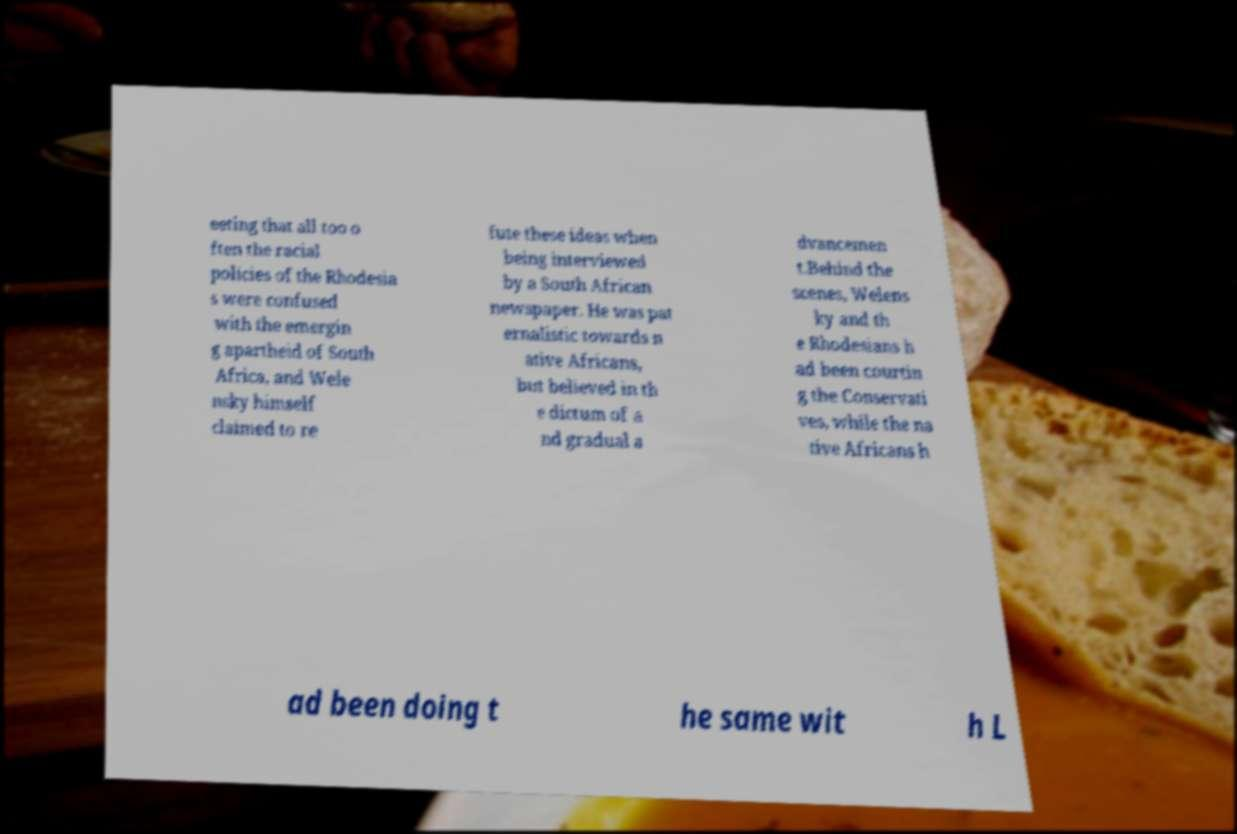Could you assist in decoding the text presented in this image and type it out clearly? eeting that all too o ften the racial policies of the Rhodesia s were confused with the emergin g apartheid of South Africa, and Wele nsky himself claimed to re fute these ideas when being interviewed by a South African newspaper. He was pat ernalistic towards n ative Africans, but believed in th e dictum of a nd gradual a dvancemen t.Behind the scenes, Welens ky and th e Rhodesians h ad been courtin g the Conservati ves, while the na tive Africans h ad been doing t he same wit h L 